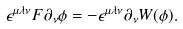<formula> <loc_0><loc_0><loc_500><loc_500>\epsilon ^ { \mu \lambda \nu } F \partial _ { \nu } \phi = - \epsilon ^ { \mu \lambda \nu } \partial _ { \nu } W ( \phi ) .</formula> 